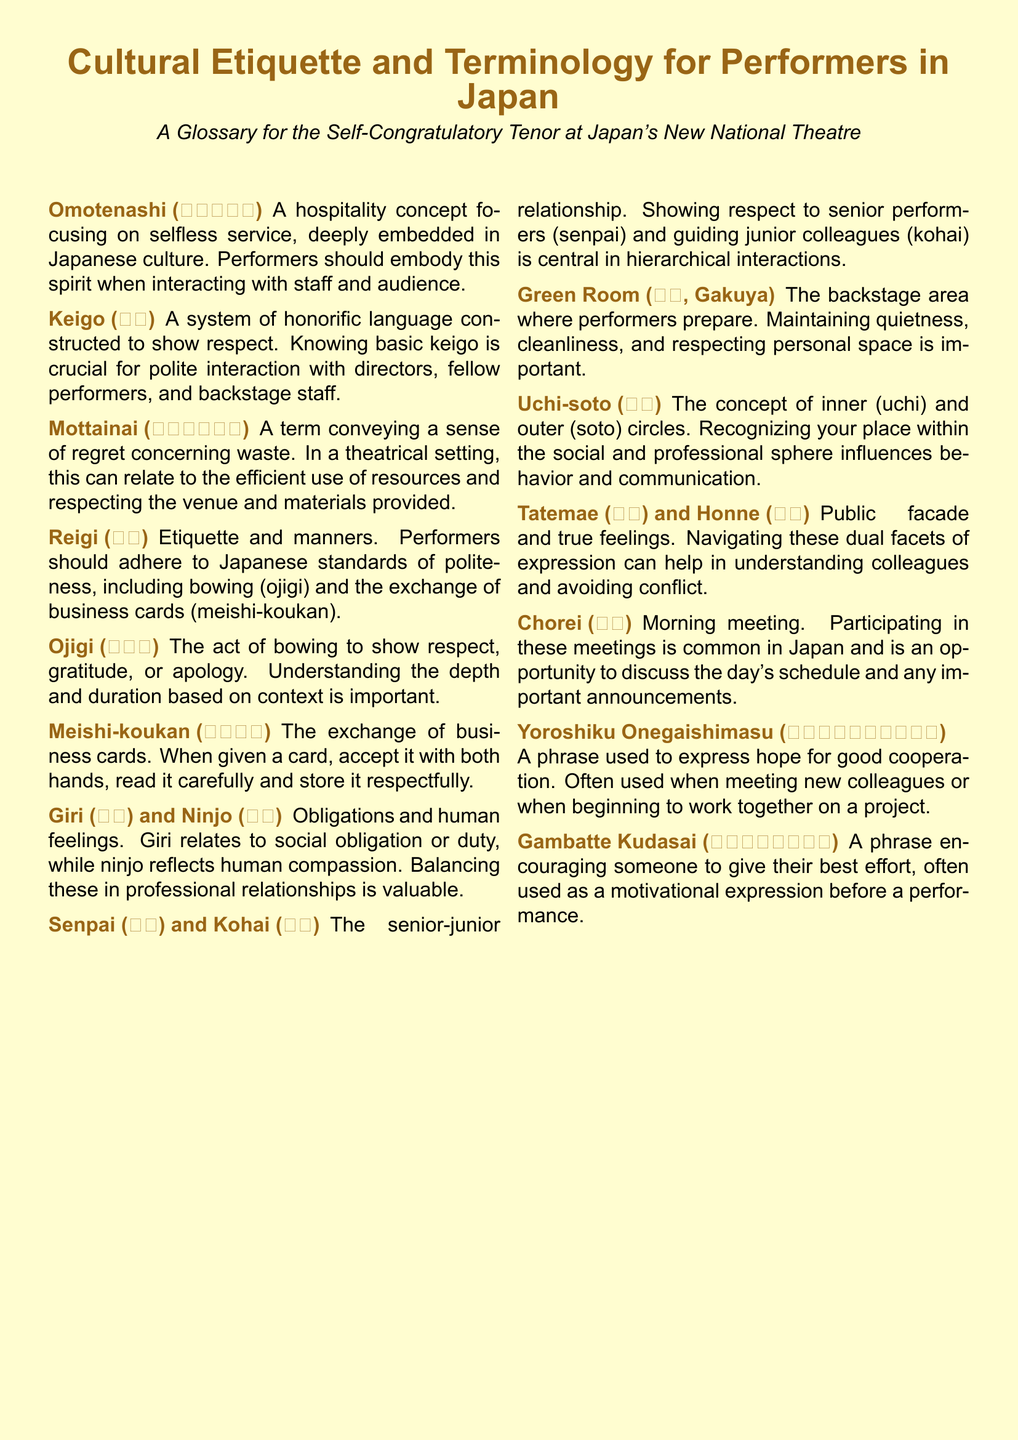What is the Japanese term for hospitality? The document defines "Omotenashi (おもてなし)" as a hospitality concept focusing on selfless service.
Answer: Omotenashi What does "Keigo (敬語)" refer to? "Keigo" is a system of honorific language constructed to show respect, essential for polite interactions.
Answer: Honorific language What is the meaning of "Mottainai (もったいない)" in a theatrical context? The term relates to a sense of regret concerning waste, focusing on the efficient use of resources in a theatre setting.
Answer: Regret concerning waste What are "Senpai (先輩) and Kohai (後輩)"? These are terms describing the senior-junior relationship within professional settings in Japan.
Answer: Senior-junior relationship What does "Ojigi (お辞儀)" signify? "Ojigi" is the act of bowing, which shows respect, gratitude, or apology depending on the context.
Answer: Bowing What should be done with a business card in Japan? The document states that when given a card, it should be accepted with both hands, read carefully, and stored respectfully.
Answer: Accepted with both hands What is the Japanese phrase to express hope for good cooperation? The document presents "Yoroshiku Onegaishimasu (よろしくお願いします)" as the phrase to indicate this sentiment.
Answer: Yoroshiku Onegaishimasu What is "Chorei (朝礼)"? "Chorei" refers to the morning meeting, which is a common practice to discuss schedules and announcements.
Answer: Morning meeting What is the backstage area called in Japanese? The term used for the backstage area where performers prepare is "Gakuya (楽屋)."
Answer: Gakuya 